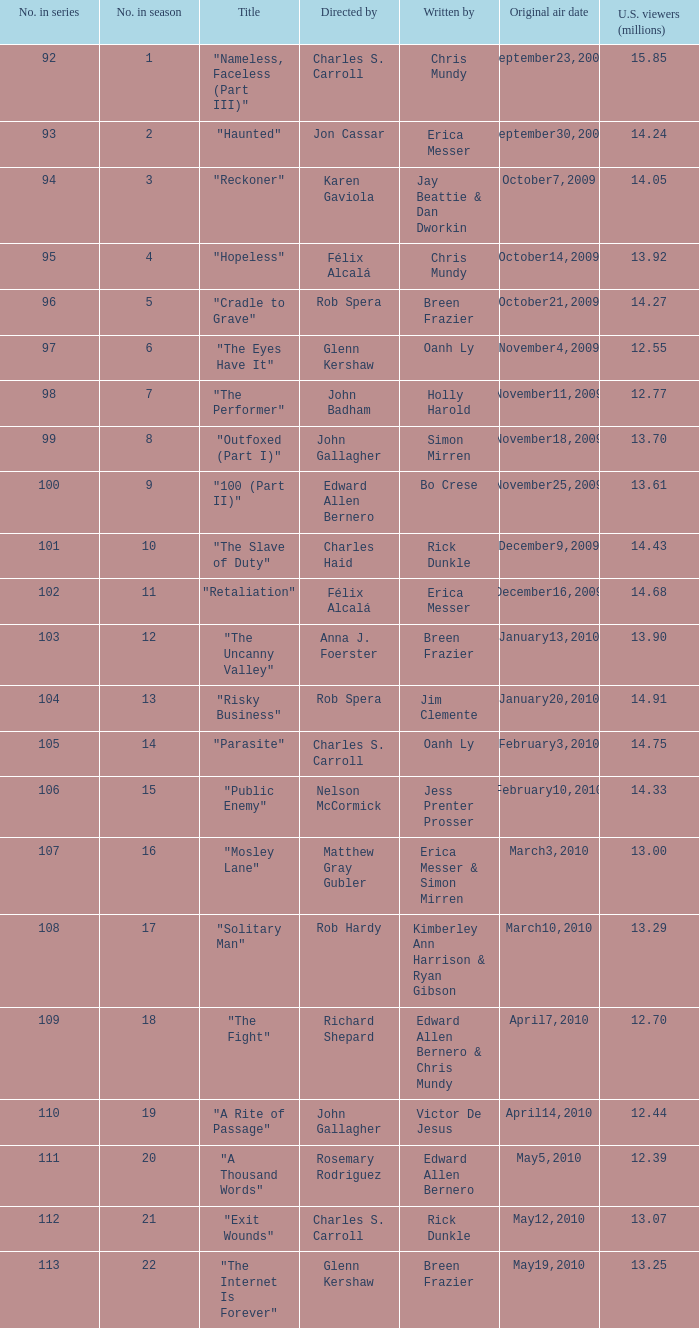Can you give me this table as a dict? {'header': ['No. in series', 'No. in season', 'Title', 'Directed by', 'Written by', 'Original air date', 'U.S. viewers (millions)'], 'rows': [['92', '1', '"Nameless, Faceless (Part III)"', 'Charles S. Carroll', 'Chris Mundy', 'September23,2009', '15.85'], ['93', '2', '"Haunted"', 'Jon Cassar', 'Erica Messer', 'September30,2009', '14.24'], ['94', '3', '"Reckoner"', 'Karen Gaviola', 'Jay Beattie & Dan Dworkin', 'October7,2009', '14.05'], ['95', '4', '"Hopeless"', 'Félix Alcalá', 'Chris Mundy', 'October14,2009', '13.92'], ['96', '5', '"Cradle to Grave"', 'Rob Spera', 'Breen Frazier', 'October21,2009', '14.27'], ['97', '6', '"The Eyes Have It"', 'Glenn Kershaw', 'Oanh Ly', 'November4,2009', '12.55'], ['98', '7', '"The Performer"', 'John Badham', 'Holly Harold', 'November11,2009', '12.77'], ['99', '8', '"Outfoxed (Part I)"', 'John Gallagher', 'Simon Mirren', 'November18,2009', '13.70'], ['100', '9', '"100 (Part II)"', 'Edward Allen Bernero', 'Bo Crese', 'November25,2009', '13.61'], ['101', '10', '"The Slave of Duty"', 'Charles Haid', 'Rick Dunkle', 'December9,2009', '14.43'], ['102', '11', '"Retaliation"', 'Félix Alcalá', 'Erica Messer', 'December16,2009', '14.68'], ['103', '12', '"The Uncanny Valley"', 'Anna J. Foerster', 'Breen Frazier', 'January13,2010', '13.90'], ['104', '13', '"Risky Business"', 'Rob Spera', 'Jim Clemente', 'January20,2010', '14.91'], ['105', '14', '"Parasite"', 'Charles S. Carroll', 'Oanh Ly', 'February3,2010', '14.75'], ['106', '15', '"Public Enemy"', 'Nelson McCormick', 'Jess Prenter Prosser', 'February10,2010', '14.33'], ['107', '16', '"Mosley Lane"', 'Matthew Gray Gubler', 'Erica Messer & Simon Mirren', 'March3,2010', '13.00'], ['108', '17', '"Solitary Man"', 'Rob Hardy', 'Kimberley Ann Harrison & Ryan Gibson', 'March10,2010', '13.29'], ['109', '18', '"The Fight"', 'Richard Shepard', 'Edward Allen Bernero & Chris Mundy', 'April7,2010', '12.70'], ['110', '19', '"A Rite of Passage"', 'John Gallagher', 'Victor De Jesus', 'April14,2010', '12.44'], ['111', '20', '"A Thousand Words"', 'Rosemary Rodriguez', 'Edward Allen Bernero', 'May5,2010', '12.39'], ['112', '21', '"Exit Wounds"', 'Charles S. Carroll', 'Rick Dunkle', 'May12,2010', '13.07'], ['113', '22', '"The Internet Is Forever"', 'Glenn Kershaw', 'Breen Frazier', 'May19,2010', '13.25']]} What season was the episode "haunted" in? 2.0. 